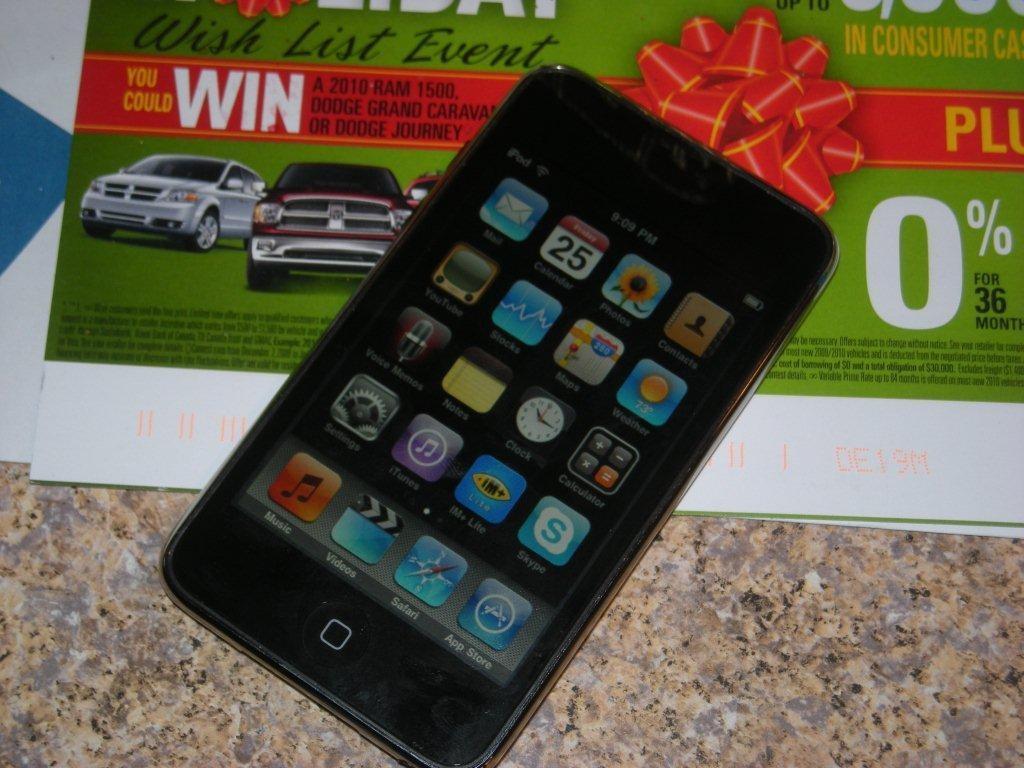Please provide a concise description of this image. In this image I can see a phone and its apps in the center of the image on a paper which is kept on the floor. 